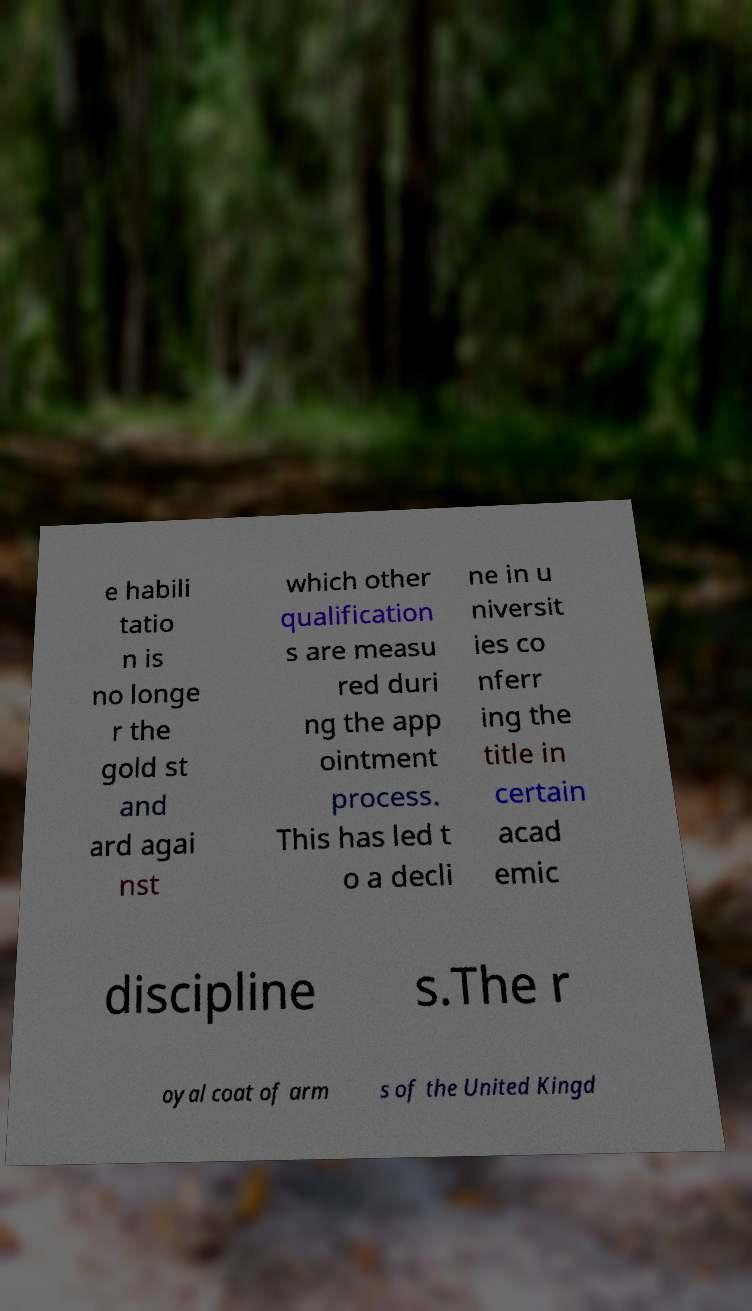Could you assist in decoding the text presented in this image and type it out clearly? e habili tatio n is no longe r the gold st and ard agai nst which other qualification s are measu red duri ng the app ointment process. This has led t o a decli ne in u niversit ies co nferr ing the title in certain acad emic discipline s.The r oyal coat of arm s of the United Kingd 